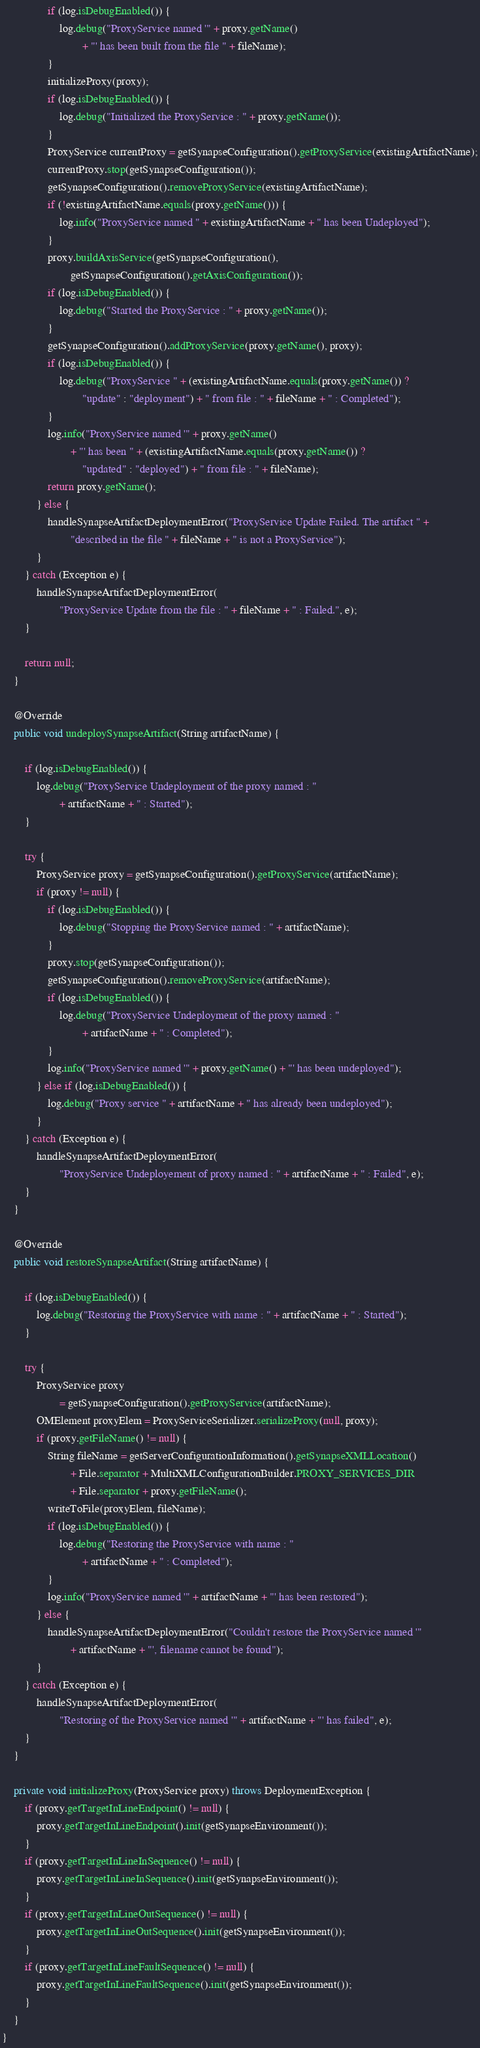Convert code to text. <code><loc_0><loc_0><loc_500><loc_500><_Java_>                if (log.isDebugEnabled()) {
                    log.debug("ProxyService named '" + proxy.getName()
                            + "' has been built from the file " + fileName);
                }
                initializeProxy(proxy);
                if (log.isDebugEnabled()) {
                    log.debug("Initialized the ProxyService : " + proxy.getName());
                }
                ProxyService currentProxy = getSynapseConfiguration().getProxyService(existingArtifactName);
                currentProxy.stop(getSynapseConfiguration());
                getSynapseConfiguration().removeProxyService(existingArtifactName);
                if (!existingArtifactName.equals(proxy.getName())) {
                    log.info("ProxyService named " + existingArtifactName + " has been Undeployed");
                }
                proxy.buildAxisService(getSynapseConfiguration(),
                        getSynapseConfiguration().getAxisConfiguration());
                if (log.isDebugEnabled()) {
                    log.debug("Started the ProxyService : " + proxy.getName());
                }
                getSynapseConfiguration().addProxyService(proxy.getName(), proxy);
                if (log.isDebugEnabled()) {
                    log.debug("ProxyService " + (existingArtifactName.equals(proxy.getName()) ?
                            "update" : "deployment") + " from file : " + fileName + " : Completed");
                }
                log.info("ProxyService named '" + proxy.getName()
                        + "' has been " + (existingArtifactName.equals(proxy.getName()) ?
                            "updated" : "deployed") + " from file : " + fileName);
                return proxy.getName();
            } else {
                handleSynapseArtifactDeploymentError("ProxyService Update Failed. The artifact " +
                        "described in the file " + fileName + " is not a ProxyService");
            }
        } catch (Exception e) {
            handleSynapseArtifactDeploymentError(
                    "ProxyService Update from the file : " + fileName + " : Failed.", e);
        }

        return null;
    }

    @Override
    public void undeploySynapseArtifact(String artifactName) {

        if (log.isDebugEnabled()) {
            log.debug("ProxyService Undeployment of the proxy named : "
                    + artifactName + " : Started");
        }
        
        try {
            ProxyService proxy = getSynapseConfiguration().getProxyService(artifactName);
            if (proxy != null) {
                if (log.isDebugEnabled()) {
                    log.debug("Stopping the ProxyService named : " + artifactName);
                }
                proxy.stop(getSynapseConfiguration());
                getSynapseConfiguration().removeProxyService(artifactName);
                if (log.isDebugEnabled()) {
                    log.debug("ProxyService Undeployment of the proxy named : "
                            + artifactName + " : Completed");
                }
                log.info("ProxyService named '" + proxy.getName() + "' has been undeployed");
            } else if (log.isDebugEnabled()) {
                log.debug("Proxy service " + artifactName + " has already been undeployed");
            }
        } catch (Exception e) {
            handleSynapseArtifactDeploymentError(
                    "ProxyService Undeployement of proxy named : " + artifactName + " : Failed", e);
        }
    }

    @Override
    public void restoreSynapseArtifact(String artifactName) {

        if (log.isDebugEnabled()) {
            log.debug("Restoring the ProxyService with name : " + artifactName + " : Started");
        }

        try {
            ProxyService proxy
                    = getSynapseConfiguration().getProxyService(artifactName);
            OMElement proxyElem = ProxyServiceSerializer.serializeProxy(null, proxy);
            if (proxy.getFileName() != null) {
                String fileName = getServerConfigurationInformation().getSynapseXMLLocation()
                        + File.separator + MultiXMLConfigurationBuilder.PROXY_SERVICES_DIR
                        + File.separator + proxy.getFileName();
                writeToFile(proxyElem, fileName);
                if (log.isDebugEnabled()) {
                    log.debug("Restoring the ProxyService with name : "
                            + artifactName + " : Completed");
                }
                log.info("ProxyService named '" + artifactName + "' has been restored");
            } else {
                handleSynapseArtifactDeploymentError("Couldn't restore the ProxyService named '"
                        + artifactName + "', filename cannot be found");
            }
        } catch (Exception e) {
            handleSynapseArtifactDeploymentError(
                    "Restoring of the ProxyService named '" + artifactName + "' has failed", e);
        }
    }

    private void initializeProxy(ProxyService proxy) throws DeploymentException {
        if (proxy.getTargetInLineEndpoint() != null) {
            proxy.getTargetInLineEndpoint().init(getSynapseEnvironment());
        }
        if (proxy.getTargetInLineInSequence() != null) {
            proxy.getTargetInLineInSequence().init(getSynapseEnvironment());
        }
        if (proxy.getTargetInLineOutSequence() != null) {
            proxy.getTargetInLineOutSequence().init(getSynapseEnvironment());
        }
        if (proxy.getTargetInLineFaultSequence() != null) {
            proxy.getTargetInLineFaultSequence().init(getSynapseEnvironment());
        }
    }
}
</code> 